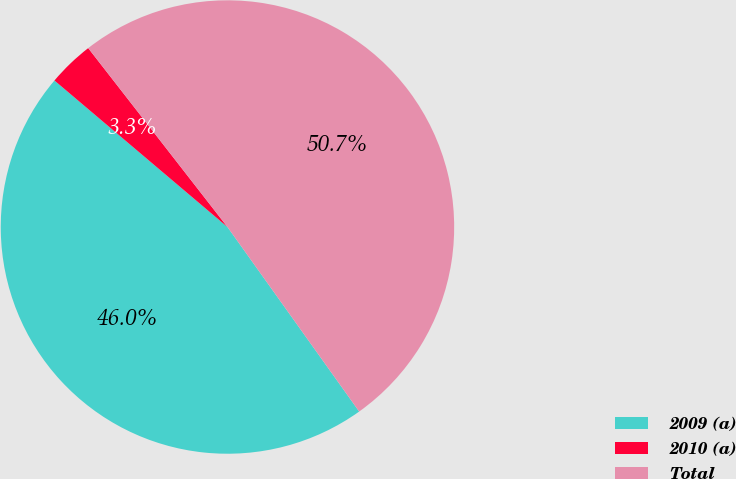<chart> <loc_0><loc_0><loc_500><loc_500><pie_chart><fcel>2009 (a)<fcel>2010 (a)<fcel>Total<nl><fcel>46.05%<fcel>3.29%<fcel>50.66%<nl></chart> 